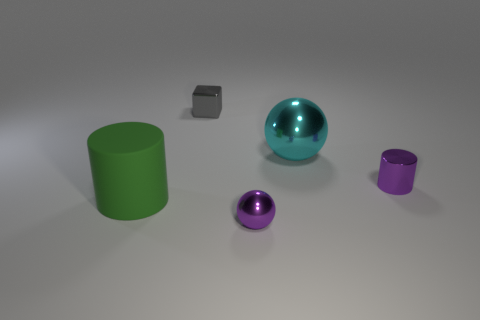There is a big object that is right of the gray metal object; what shape is it?
Provide a short and direct response. Sphere. Is there a cylinder behind the cylinder that is on the right side of the tiny gray metal thing?
Provide a short and direct response. No. How many large cyan spheres are the same material as the purple cylinder?
Your answer should be very brief. 1. There is a purple metallic thing behind the cylinder in front of the purple thing behind the small metal sphere; what size is it?
Ensure brevity in your answer.  Small. What number of big green matte cylinders are to the right of the large rubber thing?
Keep it short and to the point. 0. Are there more big cylinders than small things?
Offer a terse response. No. There is a cylinder that is the same color as the tiny metallic sphere; what is its size?
Your response must be concise. Small. There is a metallic thing that is both right of the tiny gray object and left of the big shiny thing; what is its size?
Your answer should be compact. Small. What material is the purple object in front of the cylinder that is behind the big object in front of the big metallic object?
Offer a very short reply. Metal. There is a tiny sphere that is the same color as the shiny cylinder; what material is it?
Your answer should be compact. Metal. 